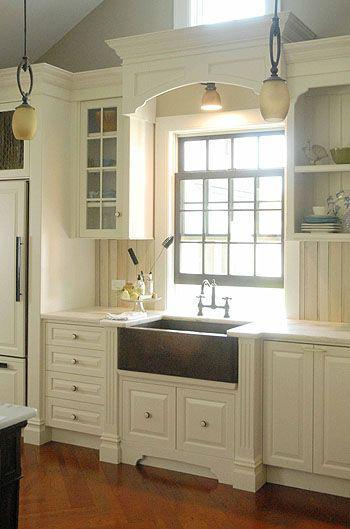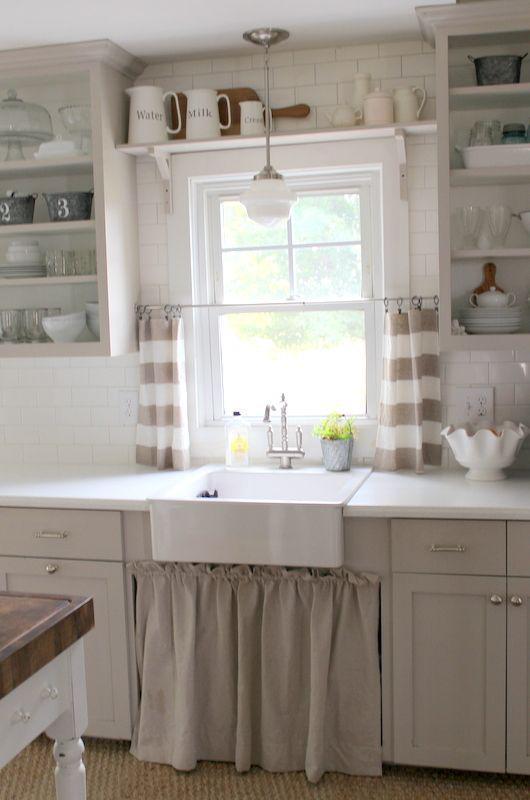The first image is the image on the left, the second image is the image on the right. Considering the images on both sides, is "Both kitchens have outside windows." valid? Answer yes or no. Yes. The first image is the image on the left, the second image is the image on the right. Analyze the images presented: Is the assertion "A plant in a container is to the left of the kitchen sink." valid? Answer yes or no. No. 